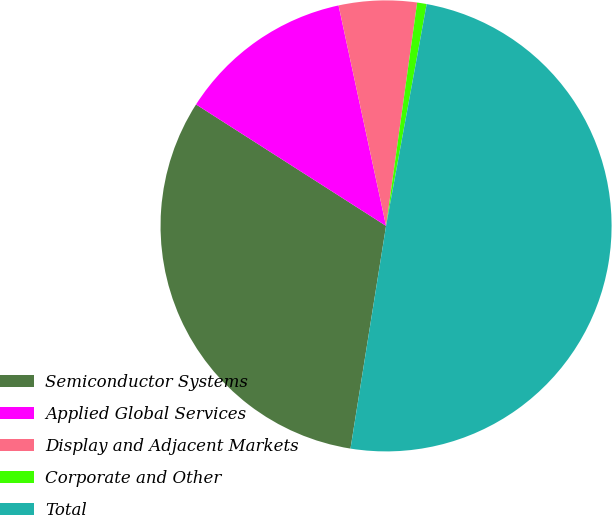<chart> <loc_0><loc_0><loc_500><loc_500><pie_chart><fcel>Semiconductor Systems<fcel>Applied Global Services<fcel>Display and Adjacent Markets<fcel>Corporate and Other<fcel>Total<nl><fcel>31.53%<fcel>12.57%<fcel>5.58%<fcel>0.68%<fcel>49.64%<nl></chart> 